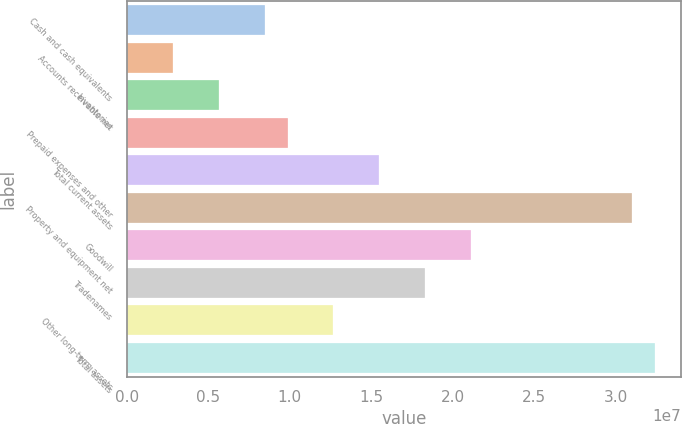<chart> <loc_0><loc_0><loc_500><loc_500><bar_chart><fcel>Cash and cash equivalents<fcel>Accounts receivable net<fcel>Inventories<fcel>Prepaid expenses and other<fcel>Total current assets<fcel>Property and equipment net<fcel>Goodwill<fcel>Tradenames<fcel>Other long-term assets<fcel>Total assets<nl><fcel>8.45701e+06<fcel>2.81916e+06<fcel>5.63809e+06<fcel>9.86648e+06<fcel>1.55043e+07<fcel>3.10084e+07<fcel>2.11422e+07<fcel>1.83233e+07<fcel>1.26854e+07<fcel>3.24179e+07<nl></chart> 